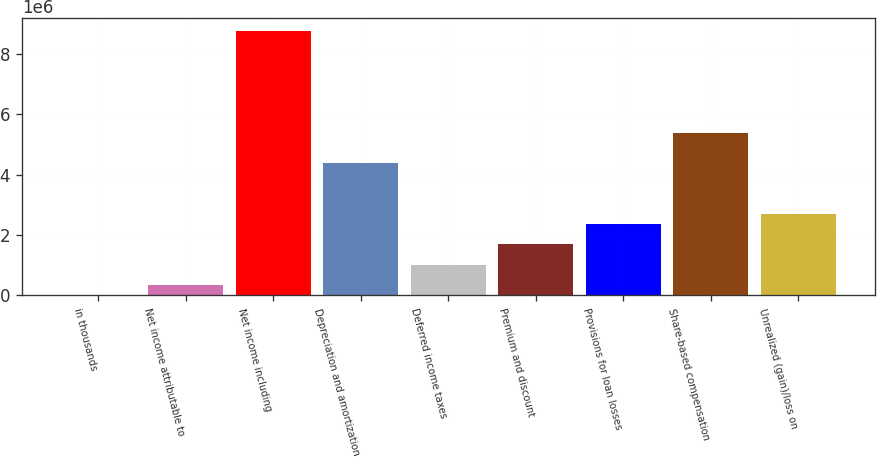<chart> <loc_0><loc_0><loc_500><loc_500><bar_chart><fcel>in thousands<fcel>Net income attributable to<fcel>Net income including<fcel>Depreciation and amortization<fcel>Deferred income taxes<fcel>Premium and discount<fcel>Provisions for loan losses<fcel>Share-based compensation<fcel>Unrealized (gain)/loss on<nl><fcel>2017<fcel>339422<fcel>8.77455e+06<fcel>4.38829e+06<fcel>1.01423e+06<fcel>1.68904e+06<fcel>2.36385e+06<fcel>5.4005e+06<fcel>2.70126e+06<nl></chart> 